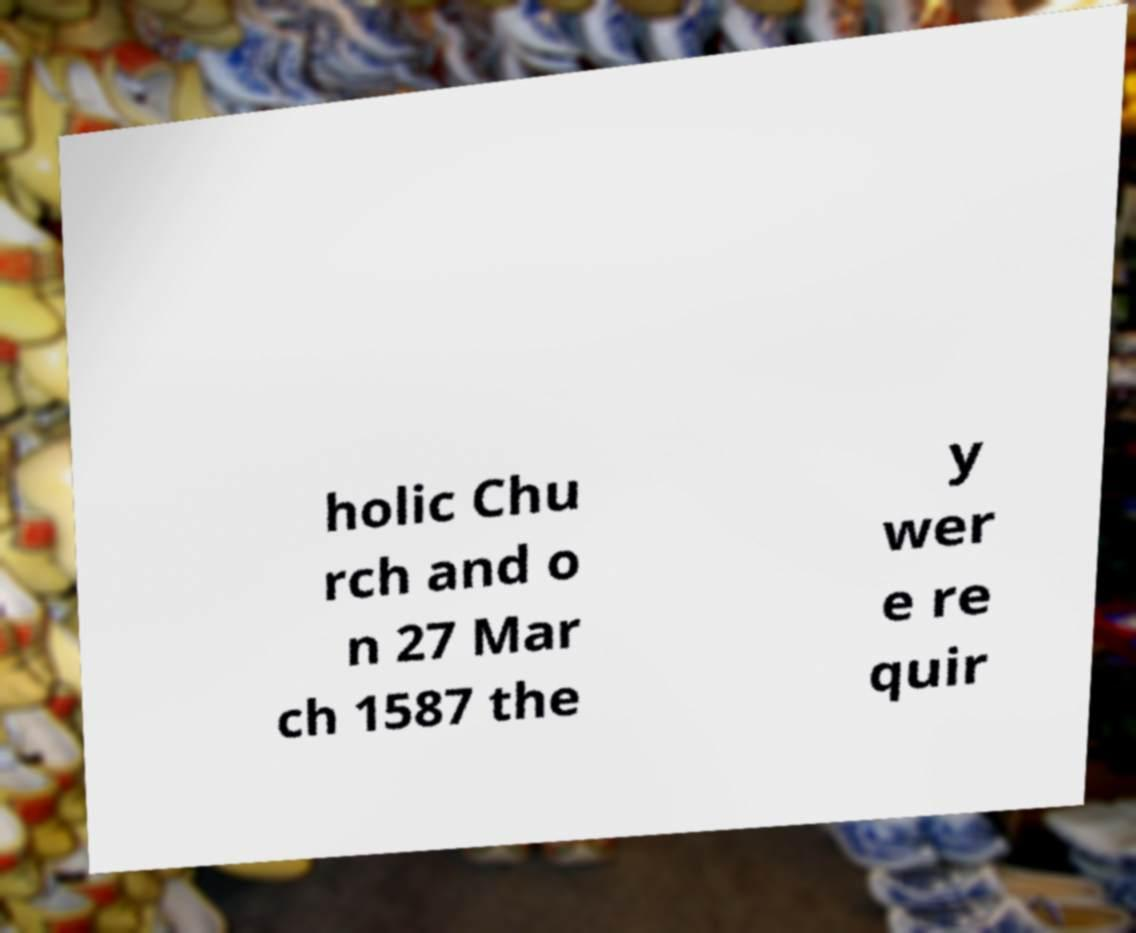Please identify and transcribe the text found in this image. holic Chu rch and o n 27 Mar ch 1587 the y wer e re quir 